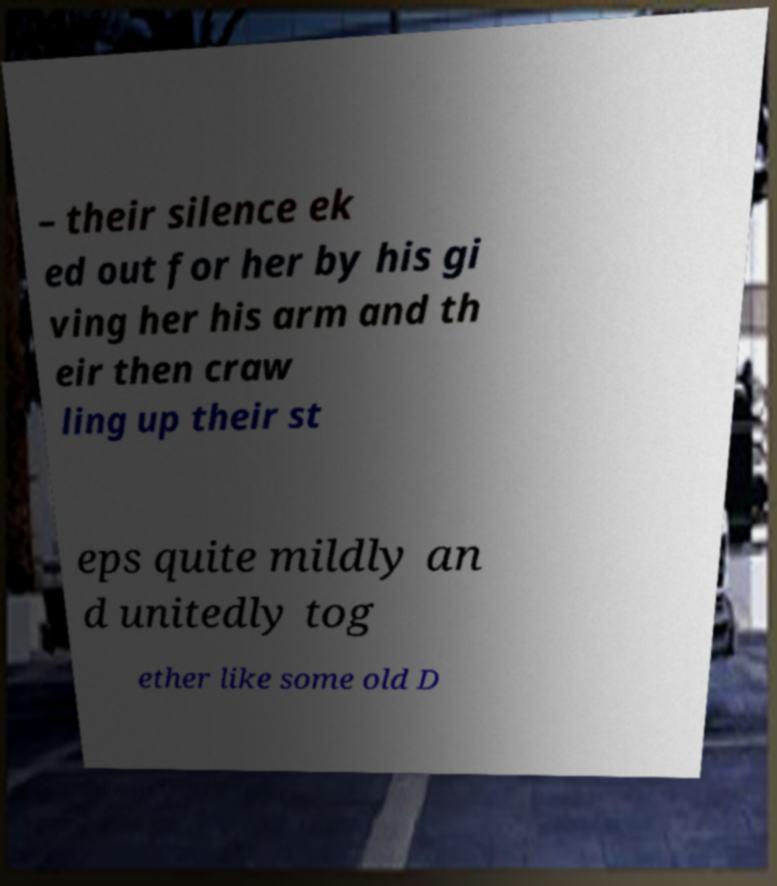Can you read and provide the text displayed in the image?This photo seems to have some interesting text. Can you extract and type it out for me? – their silence ek ed out for her by his gi ving her his arm and th eir then craw ling up their st eps quite mildly an d unitedly tog ether like some old D 